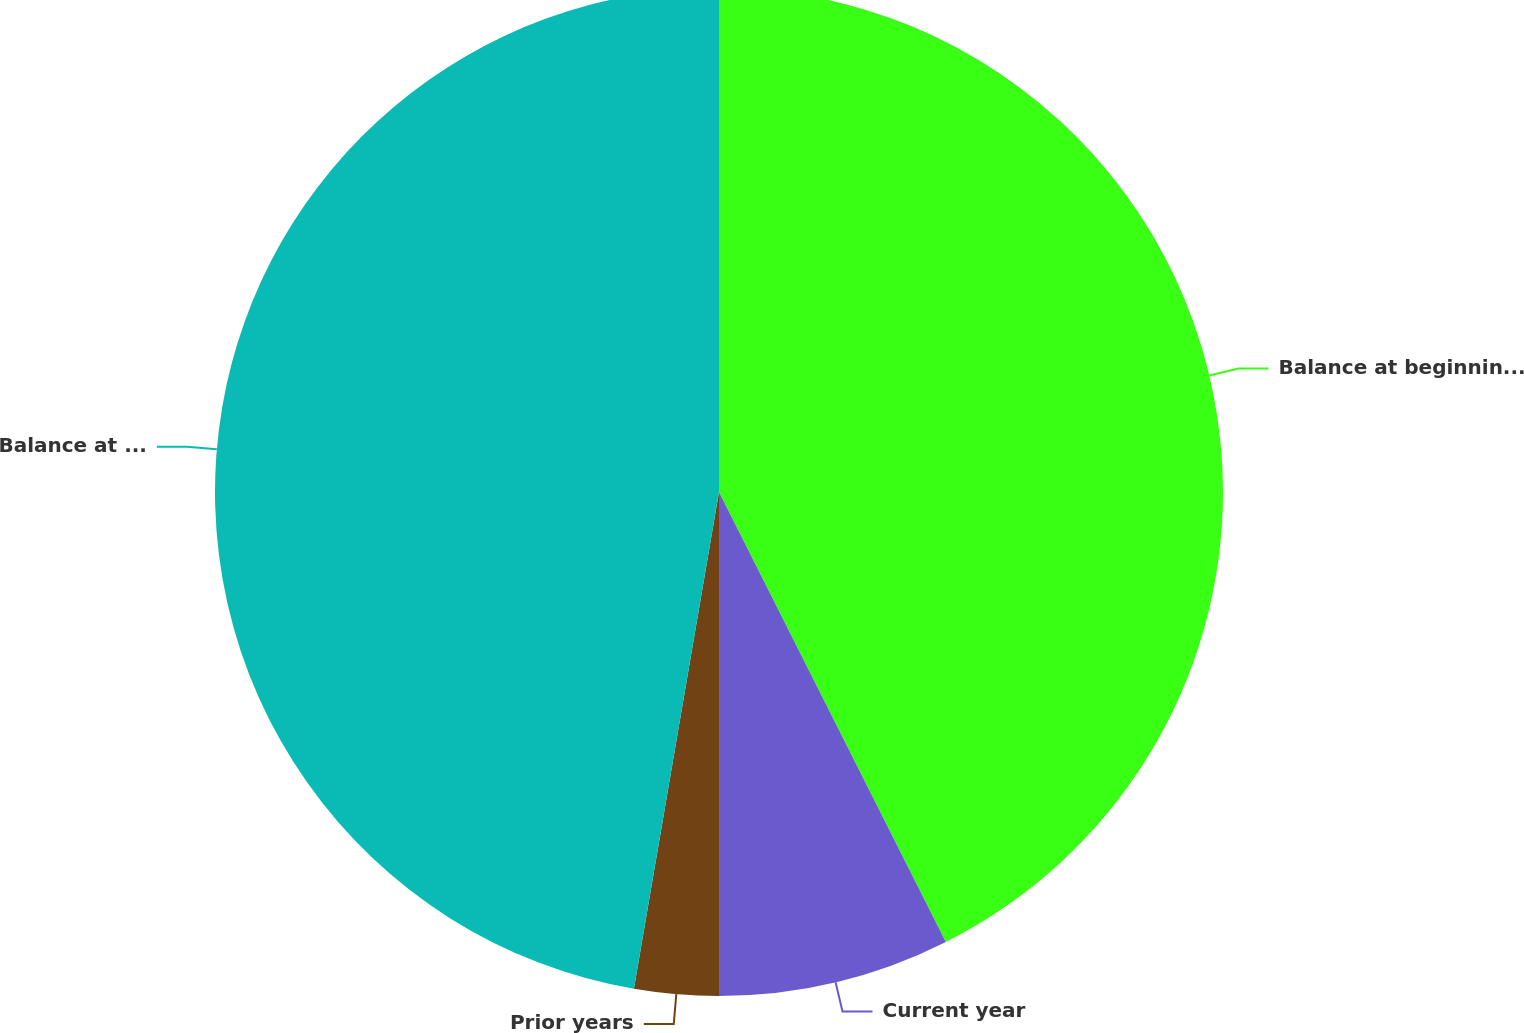<chart> <loc_0><loc_0><loc_500><loc_500><pie_chart><fcel>Balance at beginning of year<fcel>Current year<fcel>Prior years<fcel>Balance at year end<nl><fcel>42.57%<fcel>7.43%<fcel>2.7%<fcel>47.3%<nl></chart> 